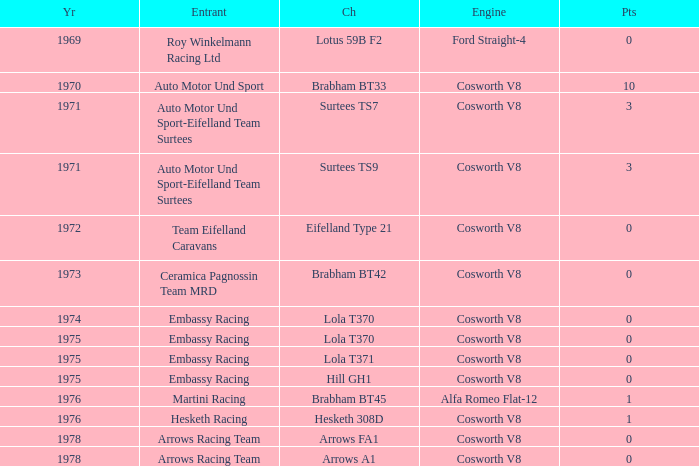What was the total amount of points in 1978 with a Chassis of arrows fa1? 0.0. 